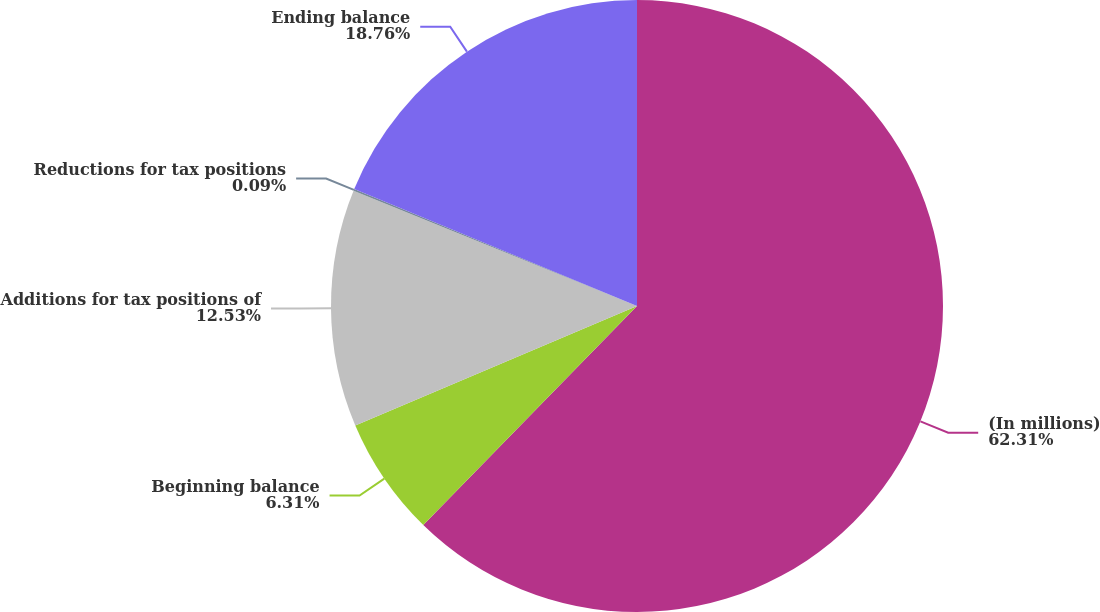Convert chart. <chart><loc_0><loc_0><loc_500><loc_500><pie_chart><fcel>(In millions)<fcel>Beginning balance<fcel>Additions for tax positions of<fcel>Reductions for tax positions<fcel>Ending balance<nl><fcel>62.3%<fcel>6.31%<fcel>12.53%<fcel>0.09%<fcel>18.76%<nl></chart> 